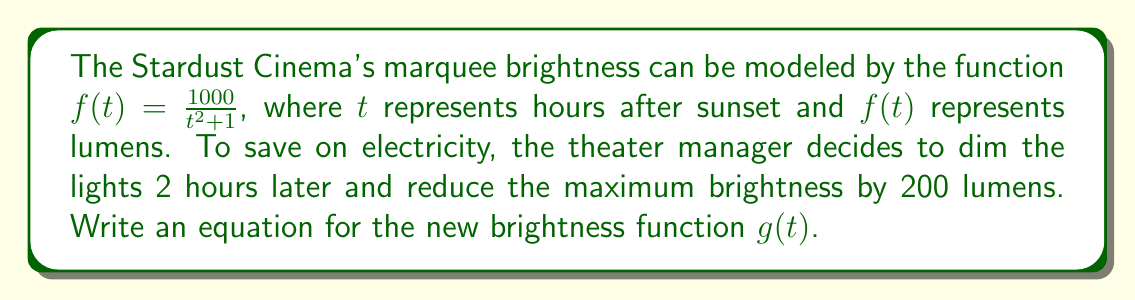Can you solve this math problem? Let's approach this step-by-step:

1) The original function is $f(t) = \frac{1000}{t^2 + 1}$

2) To dim the lights 2 hours later, we need to shift the function 2 units to the right. This is done by replacing $t$ with $(t-2)$:

   $\frac{1000}{(t-2)^2 + 1}$

3) To reduce the maximum brightness by 200 lumens, we need to subtract 200 from the function:

   $\frac{1000}{(t-2)^2 + 1} - 200$

4) However, we can't simply subtract 200 from the fraction. We need to combine this into a single fraction. To do this, we'll find a common denominator:

   $\frac{1000}{(t-2)^2 + 1} - \frac{200((t-2)^2 + 1)}{(t-2)^2 + 1}$

5) Now we can subtract the numerators:

   $\frac{1000 - 200((t-2)^2 + 1)}{(t-2)^2 + 1}$

6) Simplify the numerator:

   $\frac{1000 - 200(t^2 - 4t + 4 + 1)}{(t-2)^2 + 1}$
   $\frac{1000 - 200(t^2 - 4t + 5)}{(t-2)^2 + 1}$
   $\frac{1000 - 200t^2 + 800t - 1000}{(t-2)^2 + 1}$
   $\frac{800 - 200t^2 + 800t}{(t-2)^2 + 1}$

Therefore, the new brightness function $g(t)$ is:

$g(t) = \frac{800 - 200t^2 + 800t}{(t-2)^2 + 1}$
Answer: $g(t) = \frac{800 - 200t^2 + 800t}{(t-2)^2 + 1}$ 